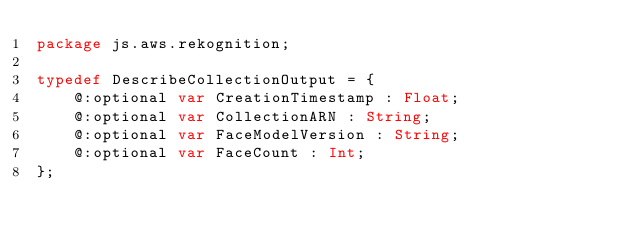Convert code to text. <code><loc_0><loc_0><loc_500><loc_500><_Haxe_>package js.aws.rekognition;

typedef DescribeCollectionOutput = {
    @:optional var CreationTimestamp : Float;
    @:optional var CollectionARN : String;
    @:optional var FaceModelVersion : String;
    @:optional var FaceCount : Int;
};
</code> 